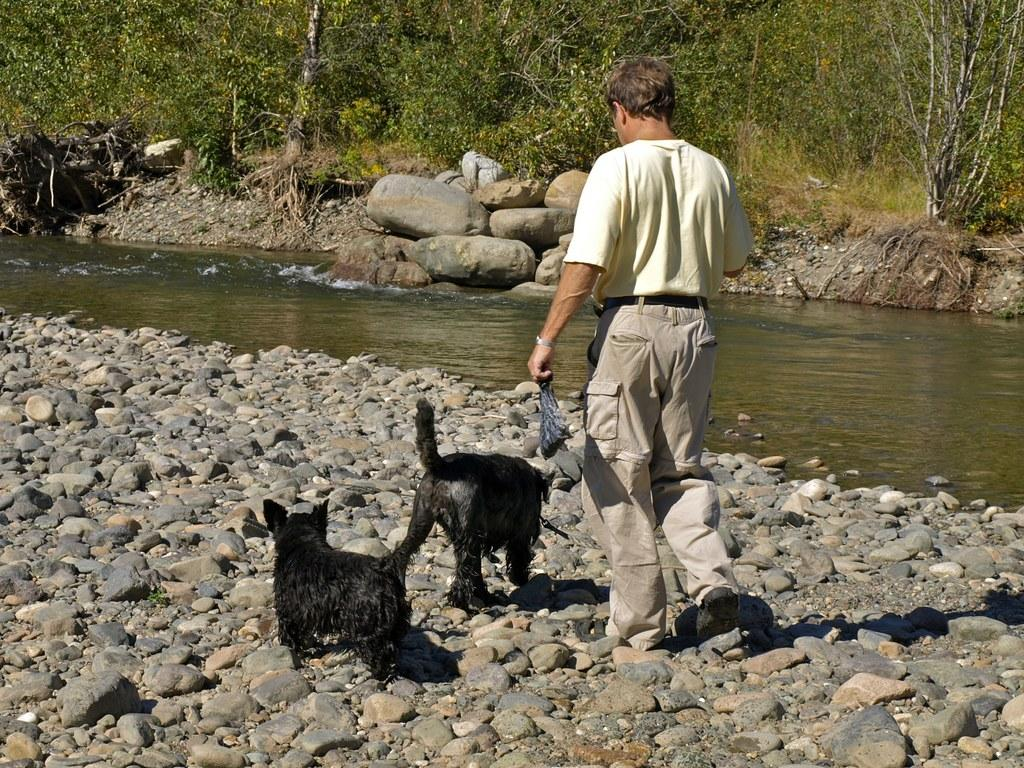Who is present in the image? There is a man in the image. What is the man doing in the image? The man is walking on stone pebbles. Are there any animals in the image? Yes, there are two black puppies in front of the man. What can be seen in the background of the image? There is a lake in the image, and it is flowing. What type of vegetation is visible in the image? There are trees at the end of the image. What type of donkey can be seen carrying a bee on its back in the image? There is no donkey or bee present in the image. How many trips does the man take to cross the lake in the image? The image does not show the man crossing the lake, so it is not possible to determine the number of trips. 